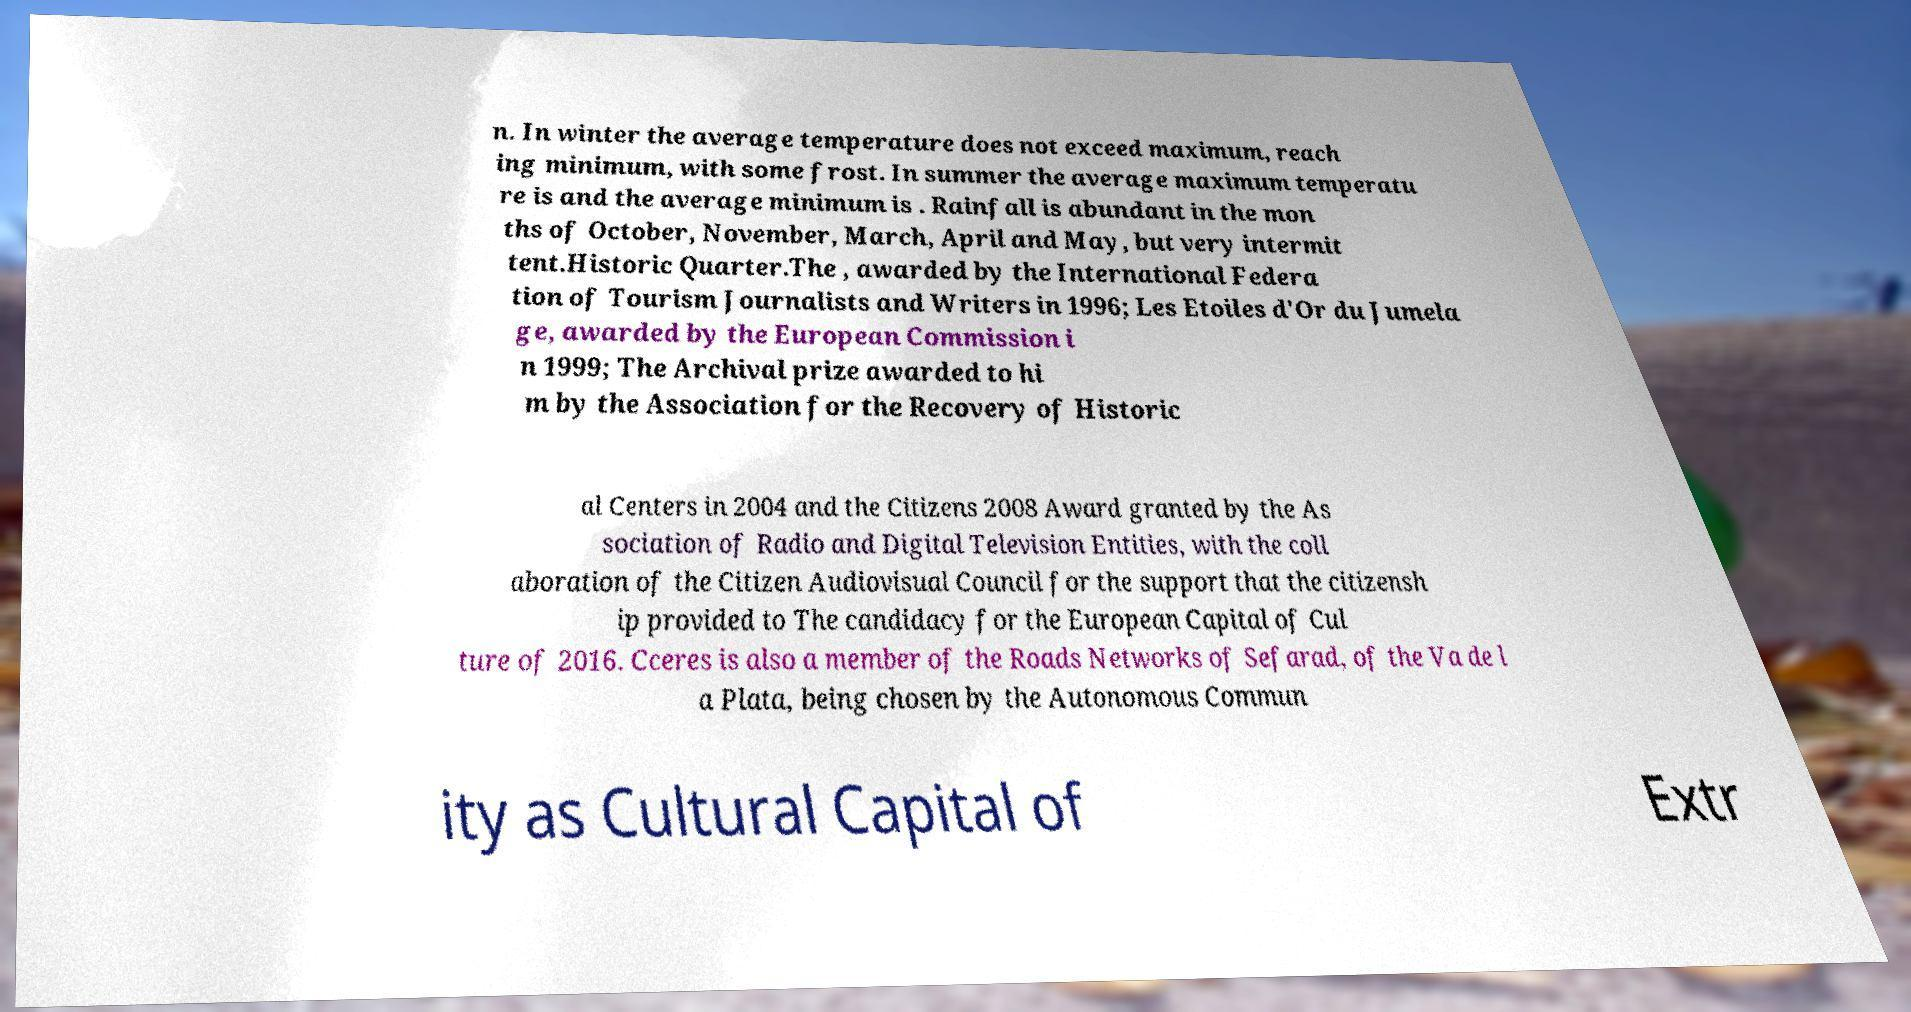What messages or text are displayed in this image? I need them in a readable, typed format. n. In winter the average temperature does not exceed maximum, reach ing minimum, with some frost. In summer the average maximum temperatu re is and the average minimum is . Rainfall is abundant in the mon ths of October, November, March, April and May, but very intermit tent.Historic Quarter.The , awarded by the International Federa tion of Tourism Journalists and Writers in 1996; Les Etoiles d'Or du Jumela ge, awarded by the European Commission i n 1999; The Archival prize awarded to hi m by the Association for the Recovery of Historic al Centers in 2004 and the Citizens 2008 Award granted by the As sociation of Radio and Digital Television Entities, with the coll aboration of the Citizen Audiovisual Council for the support that the citizensh ip provided to The candidacy for the European Capital of Cul ture of 2016. Cceres is also a member of the Roads Networks of Sefarad, of the Va de l a Plata, being chosen by the Autonomous Commun ity as Cultural Capital of Extr 